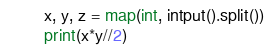Convert code to text. <code><loc_0><loc_0><loc_500><loc_500><_Python_>x, y, z = map(int, intput().split())
print(x*y//2)</code> 